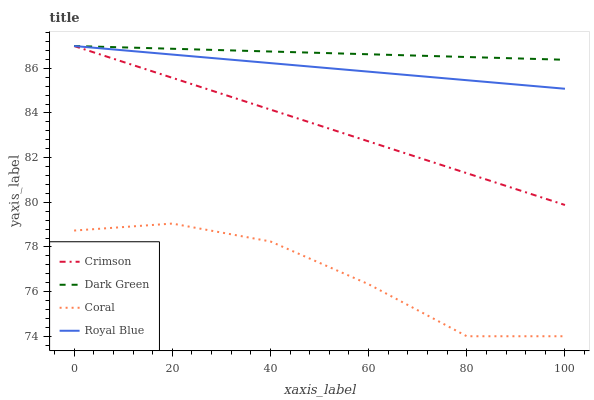Does Coral have the minimum area under the curve?
Answer yes or no. Yes. Does Dark Green have the maximum area under the curve?
Answer yes or no. Yes. Does Royal Blue have the minimum area under the curve?
Answer yes or no. No. Does Royal Blue have the maximum area under the curve?
Answer yes or no. No. Is Royal Blue the smoothest?
Answer yes or no. Yes. Is Coral the roughest?
Answer yes or no. Yes. Is Coral the smoothest?
Answer yes or no. No. Is Royal Blue the roughest?
Answer yes or no. No. Does Coral have the lowest value?
Answer yes or no. Yes. Does Royal Blue have the lowest value?
Answer yes or no. No. Does Dark Green have the highest value?
Answer yes or no. Yes. Does Coral have the highest value?
Answer yes or no. No. Is Coral less than Dark Green?
Answer yes or no. Yes. Is Dark Green greater than Coral?
Answer yes or no. Yes. Does Dark Green intersect Royal Blue?
Answer yes or no. Yes. Is Dark Green less than Royal Blue?
Answer yes or no. No. Is Dark Green greater than Royal Blue?
Answer yes or no. No. Does Coral intersect Dark Green?
Answer yes or no. No. 